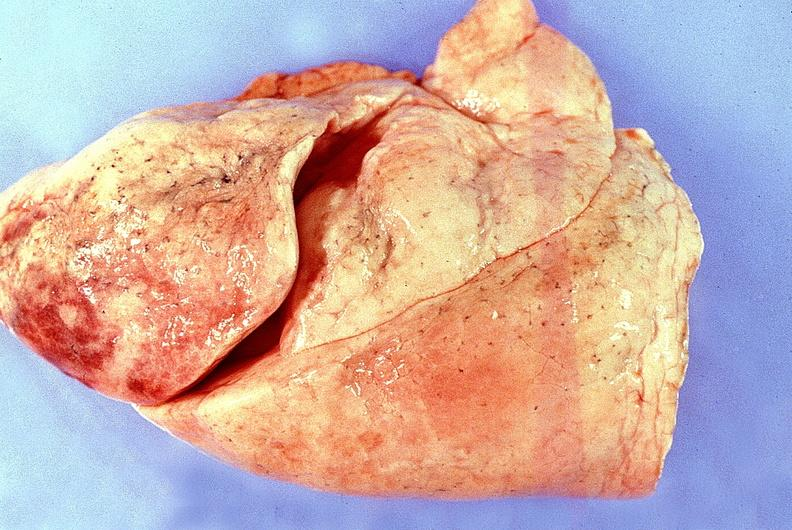what does this image show?
Answer the question using a single word or phrase. Normal lung 